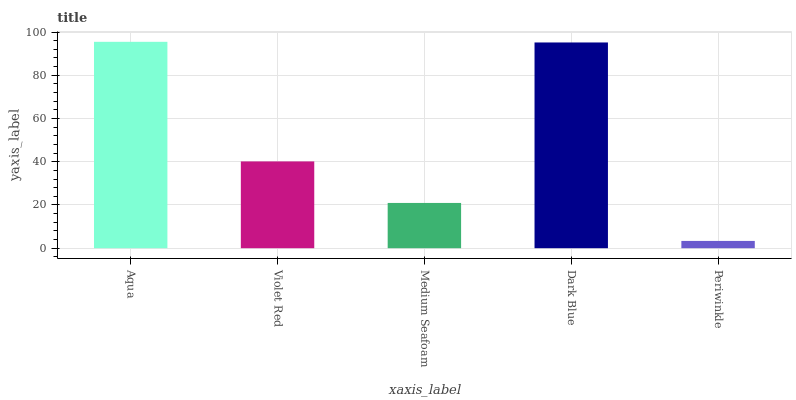Is Periwinkle the minimum?
Answer yes or no. Yes. Is Aqua the maximum?
Answer yes or no. Yes. Is Violet Red the minimum?
Answer yes or no. No. Is Violet Red the maximum?
Answer yes or no. No. Is Aqua greater than Violet Red?
Answer yes or no. Yes. Is Violet Red less than Aqua?
Answer yes or no. Yes. Is Violet Red greater than Aqua?
Answer yes or no. No. Is Aqua less than Violet Red?
Answer yes or no. No. Is Violet Red the high median?
Answer yes or no. Yes. Is Violet Red the low median?
Answer yes or no. Yes. Is Medium Seafoam the high median?
Answer yes or no. No. Is Medium Seafoam the low median?
Answer yes or no. No. 